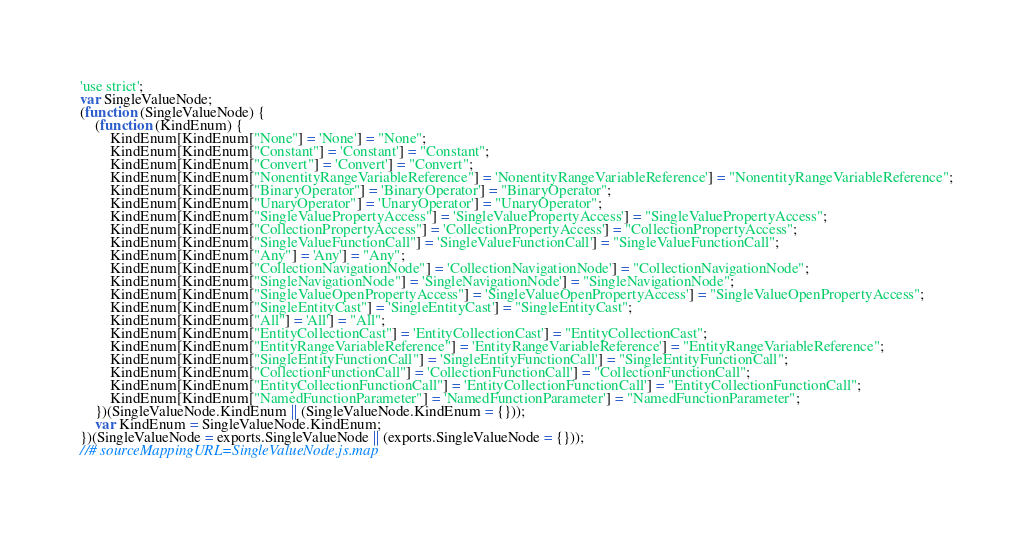Convert code to text. <code><loc_0><loc_0><loc_500><loc_500><_JavaScript_>'use strict';
var SingleValueNode;
(function (SingleValueNode) {
    (function (KindEnum) {
        KindEnum[KindEnum["None"] = 'None'] = "None";
        KindEnum[KindEnum["Constant"] = 'Constant'] = "Constant";
        KindEnum[KindEnum["Convert"] = 'Convert'] = "Convert";
        KindEnum[KindEnum["NonentityRangeVariableReference"] = 'NonentityRangeVariableReference'] = "NonentityRangeVariableReference";
        KindEnum[KindEnum["BinaryOperator"] = 'BinaryOperator'] = "BinaryOperator";
        KindEnum[KindEnum["UnaryOperator"] = 'UnaryOperator'] = "UnaryOperator";
        KindEnum[KindEnum["SingleValuePropertyAccess"] = 'SingleValuePropertyAccess'] = "SingleValuePropertyAccess";
        KindEnum[KindEnum["CollectionPropertyAccess"] = 'CollectionPropertyAccess'] = "CollectionPropertyAccess";
        KindEnum[KindEnum["SingleValueFunctionCall"] = 'SingleValueFunctionCall'] = "SingleValueFunctionCall";
        KindEnum[KindEnum["Any"] = 'Any'] = "Any";
        KindEnum[KindEnum["CollectionNavigationNode"] = 'CollectionNavigationNode'] = "CollectionNavigationNode";
        KindEnum[KindEnum["SingleNavigationNode"] = 'SingleNavigationNode'] = "SingleNavigationNode";
        KindEnum[KindEnum["SingleValueOpenPropertyAccess"] = 'SingleValueOpenPropertyAccess'] = "SingleValueOpenPropertyAccess";
        KindEnum[KindEnum["SingleEntityCast"] = 'SingleEntityCast'] = "SingleEntityCast";
        KindEnum[KindEnum["All"] = 'All'] = "All";
        KindEnum[KindEnum["EntityCollectionCast"] = 'EntityCollectionCast'] = "EntityCollectionCast";
        KindEnum[KindEnum["EntityRangeVariableReference"] = 'EntityRangeVariableReference'] = "EntityRangeVariableReference";
        KindEnum[KindEnum["SingleEntityFunctionCall"] = 'SingleEntityFunctionCall'] = "SingleEntityFunctionCall";
        KindEnum[KindEnum["CollectionFunctionCall"] = 'CollectionFunctionCall'] = "CollectionFunctionCall";
        KindEnum[KindEnum["EntityCollectionFunctionCall"] = 'EntityCollectionFunctionCall'] = "EntityCollectionFunctionCall";
        KindEnum[KindEnum["NamedFunctionParameter"] = 'NamedFunctionParameter'] = "NamedFunctionParameter";
    })(SingleValueNode.KindEnum || (SingleValueNode.KindEnum = {}));
    var KindEnum = SingleValueNode.KindEnum;
})(SingleValueNode = exports.SingleValueNode || (exports.SingleValueNode = {}));
//# sourceMappingURL=SingleValueNode.js.map</code> 